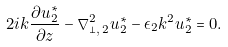Convert formula to latex. <formula><loc_0><loc_0><loc_500><loc_500>2 i k \frac { \partial u _ { 2 } ^ { \ast } } { \partial z } - \nabla _ { \perp , \, 2 } ^ { 2 } u _ { 2 } ^ { \ast } - \epsilon _ { 2 } k ^ { 2 } u _ { 2 } ^ { \ast } = 0 .</formula> 